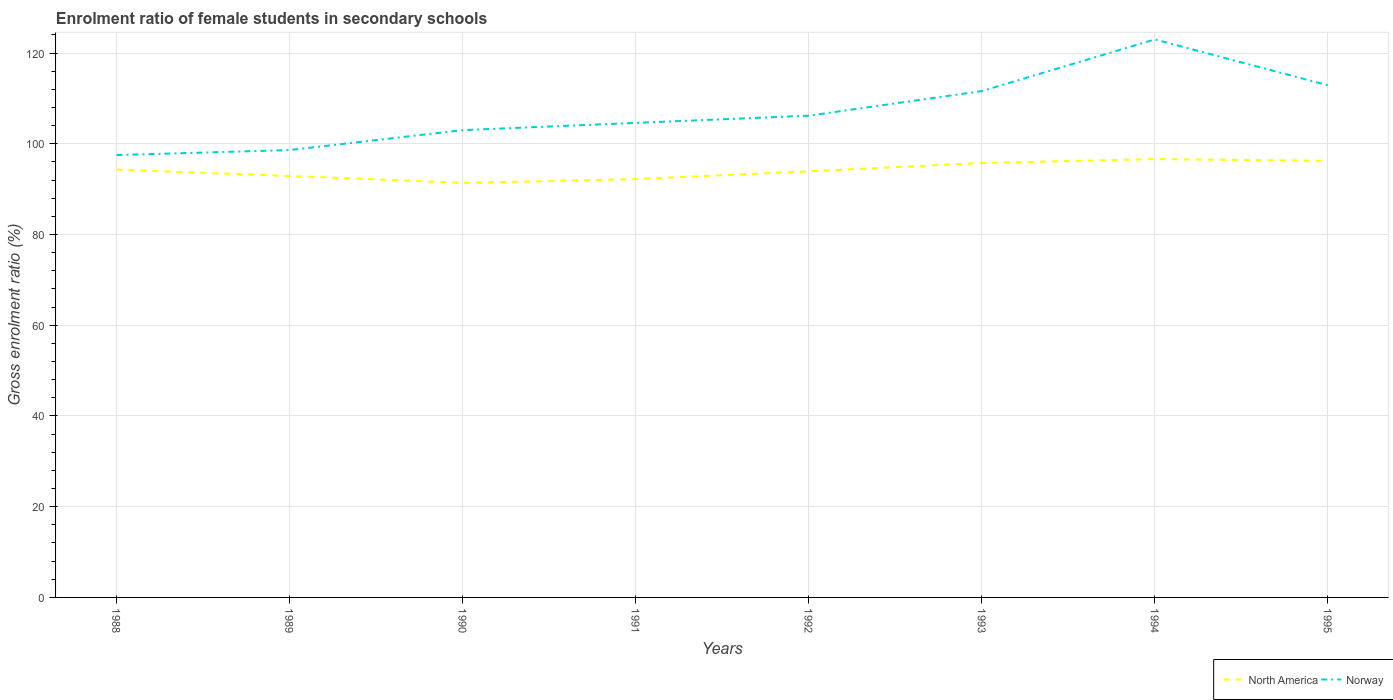How many different coloured lines are there?
Ensure brevity in your answer.  2. Across all years, what is the maximum enrolment ratio of female students in secondary schools in Norway?
Offer a terse response. 97.5. What is the total enrolment ratio of female students in secondary schools in Norway in the graph?
Offer a terse response. -24.39. What is the difference between the highest and the second highest enrolment ratio of female students in secondary schools in North America?
Offer a terse response. 5.23. Is the enrolment ratio of female students in secondary schools in Norway strictly greater than the enrolment ratio of female students in secondary schools in North America over the years?
Provide a short and direct response. No. How many years are there in the graph?
Ensure brevity in your answer.  8. What is the difference between two consecutive major ticks on the Y-axis?
Provide a succinct answer. 20. Are the values on the major ticks of Y-axis written in scientific E-notation?
Make the answer very short. No. How are the legend labels stacked?
Your answer should be very brief. Horizontal. What is the title of the graph?
Your answer should be compact. Enrolment ratio of female students in secondary schools. What is the label or title of the X-axis?
Your answer should be compact. Years. What is the Gross enrolment ratio (%) of North America in 1988?
Offer a terse response. 94.3. What is the Gross enrolment ratio (%) of Norway in 1988?
Offer a terse response. 97.5. What is the Gross enrolment ratio (%) of North America in 1989?
Offer a very short reply. 92.91. What is the Gross enrolment ratio (%) of Norway in 1989?
Your response must be concise. 98.61. What is the Gross enrolment ratio (%) in North America in 1990?
Your answer should be very brief. 91.39. What is the Gross enrolment ratio (%) of Norway in 1990?
Give a very brief answer. 103. What is the Gross enrolment ratio (%) of North America in 1991?
Offer a terse response. 92.21. What is the Gross enrolment ratio (%) of Norway in 1991?
Give a very brief answer. 104.6. What is the Gross enrolment ratio (%) of North America in 1992?
Your response must be concise. 93.93. What is the Gross enrolment ratio (%) in Norway in 1992?
Your answer should be compact. 106.19. What is the Gross enrolment ratio (%) in North America in 1993?
Make the answer very short. 95.76. What is the Gross enrolment ratio (%) in Norway in 1993?
Offer a terse response. 111.61. What is the Gross enrolment ratio (%) of North America in 1994?
Your response must be concise. 96.62. What is the Gross enrolment ratio (%) of Norway in 1994?
Keep it short and to the point. 123. What is the Gross enrolment ratio (%) in North America in 1995?
Your response must be concise. 96.25. What is the Gross enrolment ratio (%) in Norway in 1995?
Provide a short and direct response. 112.89. Across all years, what is the maximum Gross enrolment ratio (%) in North America?
Provide a succinct answer. 96.62. Across all years, what is the maximum Gross enrolment ratio (%) in Norway?
Your answer should be very brief. 123. Across all years, what is the minimum Gross enrolment ratio (%) in North America?
Keep it short and to the point. 91.39. Across all years, what is the minimum Gross enrolment ratio (%) in Norway?
Your response must be concise. 97.5. What is the total Gross enrolment ratio (%) in North America in the graph?
Ensure brevity in your answer.  753.37. What is the total Gross enrolment ratio (%) of Norway in the graph?
Offer a terse response. 857.42. What is the difference between the Gross enrolment ratio (%) of North America in 1988 and that in 1989?
Ensure brevity in your answer.  1.39. What is the difference between the Gross enrolment ratio (%) of Norway in 1988 and that in 1989?
Your answer should be very brief. -1.11. What is the difference between the Gross enrolment ratio (%) of North America in 1988 and that in 1990?
Offer a terse response. 2.91. What is the difference between the Gross enrolment ratio (%) in Norway in 1988 and that in 1990?
Your answer should be very brief. -5.5. What is the difference between the Gross enrolment ratio (%) of North America in 1988 and that in 1991?
Your response must be concise. 2.09. What is the difference between the Gross enrolment ratio (%) in Norway in 1988 and that in 1991?
Provide a short and direct response. -7.1. What is the difference between the Gross enrolment ratio (%) of North America in 1988 and that in 1992?
Offer a very short reply. 0.36. What is the difference between the Gross enrolment ratio (%) in Norway in 1988 and that in 1992?
Make the answer very short. -8.69. What is the difference between the Gross enrolment ratio (%) in North America in 1988 and that in 1993?
Give a very brief answer. -1.47. What is the difference between the Gross enrolment ratio (%) of Norway in 1988 and that in 1993?
Offer a very short reply. -14.11. What is the difference between the Gross enrolment ratio (%) of North America in 1988 and that in 1994?
Ensure brevity in your answer.  -2.32. What is the difference between the Gross enrolment ratio (%) in Norway in 1988 and that in 1994?
Ensure brevity in your answer.  -25.5. What is the difference between the Gross enrolment ratio (%) in North America in 1988 and that in 1995?
Your answer should be very brief. -1.96. What is the difference between the Gross enrolment ratio (%) in Norway in 1988 and that in 1995?
Offer a very short reply. -15.39. What is the difference between the Gross enrolment ratio (%) in North America in 1989 and that in 1990?
Make the answer very short. 1.52. What is the difference between the Gross enrolment ratio (%) of Norway in 1989 and that in 1990?
Ensure brevity in your answer.  -4.39. What is the difference between the Gross enrolment ratio (%) in North America in 1989 and that in 1991?
Offer a very short reply. 0.7. What is the difference between the Gross enrolment ratio (%) of Norway in 1989 and that in 1991?
Offer a very short reply. -5.99. What is the difference between the Gross enrolment ratio (%) in North America in 1989 and that in 1992?
Your response must be concise. -1.03. What is the difference between the Gross enrolment ratio (%) of Norway in 1989 and that in 1992?
Ensure brevity in your answer.  -7.58. What is the difference between the Gross enrolment ratio (%) in North America in 1989 and that in 1993?
Offer a very short reply. -2.86. What is the difference between the Gross enrolment ratio (%) of Norway in 1989 and that in 1993?
Your answer should be very brief. -13. What is the difference between the Gross enrolment ratio (%) in North America in 1989 and that in 1994?
Keep it short and to the point. -3.71. What is the difference between the Gross enrolment ratio (%) of Norway in 1989 and that in 1994?
Give a very brief answer. -24.39. What is the difference between the Gross enrolment ratio (%) in North America in 1989 and that in 1995?
Your answer should be compact. -3.35. What is the difference between the Gross enrolment ratio (%) of Norway in 1989 and that in 1995?
Offer a very short reply. -14.28. What is the difference between the Gross enrolment ratio (%) of North America in 1990 and that in 1991?
Keep it short and to the point. -0.82. What is the difference between the Gross enrolment ratio (%) in Norway in 1990 and that in 1991?
Make the answer very short. -1.6. What is the difference between the Gross enrolment ratio (%) of North America in 1990 and that in 1992?
Offer a terse response. -2.55. What is the difference between the Gross enrolment ratio (%) in Norway in 1990 and that in 1992?
Offer a terse response. -3.19. What is the difference between the Gross enrolment ratio (%) of North America in 1990 and that in 1993?
Give a very brief answer. -4.38. What is the difference between the Gross enrolment ratio (%) of Norway in 1990 and that in 1993?
Provide a succinct answer. -8.61. What is the difference between the Gross enrolment ratio (%) in North America in 1990 and that in 1994?
Keep it short and to the point. -5.23. What is the difference between the Gross enrolment ratio (%) in Norway in 1990 and that in 1994?
Offer a very short reply. -20. What is the difference between the Gross enrolment ratio (%) of North America in 1990 and that in 1995?
Your response must be concise. -4.87. What is the difference between the Gross enrolment ratio (%) in Norway in 1990 and that in 1995?
Provide a succinct answer. -9.89. What is the difference between the Gross enrolment ratio (%) of North America in 1991 and that in 1992?
Keep it short and to the point. -1.73. What is the difference between the Gross enrolment ratio (%) in Norway in 1991 and that in 1992?
Ensure brevity in your answer.  -1.58. What is the difference between the Gross enrolment ratio (%) of North America in 1991 and that in 1993?
Your response must be concise. -3.56. What is the difference between the Gross enrolment ratio (%) of Norway in 1991 and that in 1993?
Offer a very short reply. -7.01. What is the difference between the Gross enrolment ratio (%) in North America in 1991 and that in 1994?
Make the answer very short. -4.41. What is the difference between the Gross enrolment ratio (%) of Norway in 1991 and that in 1994?
Your response must be concise. -18.4. What is the difference between the Gross enrolment ratio (%) of North America in 1991 and that in 1995?
Your answer should be compact. -4.05. What is the difference between the Gross enrolment ratio (%) in Norway in 1991 and that in 1995?
Your response must be concise. -8.29. What is the difference between the Gross enrolment ratio (%) in North America in 1992 and that in 1993?
Keep it short and to the point. -1.83. What is the difference between the Gross enrolment ratio (%) of Norway in 1992 and that in 1993?
Your answer should be very brief. -5.42. What is the difference between the Gross enrolment ratio (%) in North America in 1992 and that in 1994?
Provide a succinct answer. -2.69. What is the difference between the Gross enrolment ratio (%) of Norway in 1992 and that in 1994?
Your response must be concise. -16.81. What is the difference between the Gross enrolment ratio (%) of North America in 1992 and that in 1995?
Provide a short and direct response. -2.32. What is the difference between the Gross enrolment ratio (%) of Norway in 1992 and that in 1995?
Ensure brevity in your answer.  -6.7. What is the difference between the Gross enrolment ratio (%) in North America in 1993 and that in 1994?
Make the answer very short. -0.86. What is the difference between the Gross enrolment ratio (%) in Norway in 1993 and that in 1994?
Keep it short and to the point. -11.39. What is the difference between the Gross enrolment ratio (%) in North America in 1993 and that in 1995?
Ensure brevity in your answer.  -0.49. What is the difference between the Gross enrolment ratio (%) of Norway in 1993 and that in 1995?
Keep it short and to the point. -1.28. What is the difference between the Gross enrolment ratio (%) in North America in 1994 and that in 1995?
Ensure brevity in your answer.  0.37. What is the difference between the Gross enrolment ratio (%) in Norway in 1994 and that in 1995?
Make the answer very short. 10.11. What is the difference between the Gross enrolment ratio (%) of North America in 1988 and the Gross enrolment ratio (%) of Norway in 1989?
Offer a very short reply. -4.32. What is the difference between the Gross enrolment ratio (%) in North America in 1988 and the Gross enrolment ratio (%) in Norway in 1990?
Your answer should be very brief. -8.71. What is the difference between the Gross enrolment ratio (%) of North America in 1988 and the Gross enrolment ratio (%) of Norway in 1991?
Offer a terse response. -10.31. What is the difference between the Gross enrolment ratio (%) of North America in 1988 and the Gross enrolment ratio (%) of Norway in 1992?
Make the answer very short. -11.89. What is the difference between the Gross enrolment ratio (%) of North America in 1988 and the Gross enrolment ratio (%) of Norway in 1993?
Offer a terse response. -17.32. What is the difference between the Gross enrolment ratio (%) of North America in 1988 and the Gross enrolment ratio (%) of Norway in 1994?
Offer a very short reply. -28.71. What is the difference between the Gross enrolment ratio (%) of North America in 1988 and the Gross enrolment ratio (%) of Norway in 1995?
Ensure brevity in your answer.  -18.6. What is the difference between the Gross enrolment ratio (%) in North America in 1989 and the Gross enrolment ratio (%) in Norway in 1990?
Your answer should be very brief. -10.1. What is the difference between the Gross enrolment ratio (%) of North America in 1989 and the Gross enrolment ratio (%) of Norway in 1991?
Give a very brief answer. -11.7. What is the difference between the Gross enrolment ratio (%) of North America in 1989 and the Gross enrolment ratio (%) of Norway in 1992?
Provide a short and direct response. -13.28. What is the difference between the Gross enrolment ratio (%) of North America in 1989 and the Gross enrolment ratio (%) of Norway in 1993?
Your answer should be compact. -18.7. What is the difference between the Gross enrolment ratio (%) of North America in 1989 and the Gross enrolment ratio (%) of Norway in 1994?
Offer a terse response. -30.09. What is the difference between the Gross enrolment ratio (%) in North America in 1989 and the Gross enrolment ratio (%) in Norway in 1995?
Offer a terse response. -19.98. What is the difference between the Gross enrolment ratio (%) in North America in 1990 and the Gross enrolment ratio (%) in Norway in 1991?
Your response must be concise. -13.22. What is the difference between the Gross enrolment ratio (%) of North America in 1990 and the Gross enrolment ratio (%) of Norway in 1992?
Give a very brief answer. -14.8. What is the difference between the Gross enrolment ratio (%) in North America in 1990 and the Gross enrolment ratio (%) in Norway in 1993?
Provide a short and direct response. -20.22. What is the difference between the Gross enrolment ratio (%) of North America in 1990 and the Gross enrolment ratio (%) of Norway in 1994?
Give a very brief answer. -31.61. What is the difference between the Gross enrolment ratio (%) in North America in 1990 and the Gross enrolment ratio (%) in Norway in 1995?
Ensure brevity in your answer.  -21.51. What is the difference between the Gross enrolment ratio (%) of North America in 1991 and the Gross enrolment ratio (%) of Norway in 1992?
Provide a short and direct response. -13.98. What is the difference between the Gross enrolment ratio (%) of North America in 1991 and the Gross enrolment ratio (%) of Norway in 1993?
Give a very brief answer. -19.4. What is the difference between the Gross enrolment ratio (%) in North America in 1991 and the Gross enrolment ratio (%) in Norway in 1994?
Your answer should be very brief. -30.79. What is the difference between the Gross enrolment ratio (%) in North America in 1991 and the Gross enrolment ratio (%) in Norway in 1995?
Keep it short and to the point. -20.68. What is the difference between the Gross enrolment ratio (%) of North America in 1992 and the Gross enrolment ratio (%) of Norway in 1993?
Give a very brief answer. -17.68. What is the difference between the Gross enrolment ratio (%) of North America in 1992 and the Gross enrolment ratio (%) of Norway in 1994?
Give a very brief answer. -29.07. What is the difference between the Gross enrolment ratio (%) in North America in 1992 and the Gross enrolment ratio (%) in Norway in 1995?
Your response must be concise. -18.96. What is the difference between the Gross enrolment ratio (%) in North America in 1993 and the Gross enrolment ratio (%) in Norway in 1994?
Give a very brief answer. -27.24. What is the difference between the Gross enrolment ratio (%) of North America in 1993 and the Gross enrolment ratio (%) of Norway in 1995?
Make the answer very short. -17.13. What is the difference between the Gross enrolment ratio (%) in North America in 1994 and the Gross enrolment ratio (%) in Norway in 1995?
Give a very brief answer. -16.27. What is the average Gross enrolment ratio (%) of North America per year?
Your answer should be compact. 94.17. What is the average Gross enrolment ratio (%) of Norway per year?
Offer a very short reply. 107.18. In the year 1988, what is the difference between the Gross enrolment ratio (%) of North America and Gross enrolment ratio (%) of Norway?
Offer a terse response. -3.21. In the year 1989, what is the difference between the Gross enrolment ratio (%) in North America and Gross enrolment ratio (%) in Norway?
Give a very brief answer. -5.71. In the year 1990, what is the difference between the Gross enrolment ratio (%) of North America and Gross enrolment ratio (%) of Norway?
Provide a succinct answer. -11.62. In the year 1991, what is the difference between the Gross enrolment ratio (%) of North America and Gross enrolment ratio (%) of Norway?
Your response must be concise. -12.4. In the year 1992, what is the difference between the Gross enrolment ratio (%) of North America and Gross enrolment ratio (%) of Norway?
Your response must be concise. -12.26. In the year 1993, what is the difference between the Gross enrolment ratio (%) in North America and Gross enrolment ratio (%) in Norway?
Offer a terse response. -15.85. In the year 1994, what is the difference between the Gross enrolment ratio (%) of North America and Gross enrolment ratio (%) of Norway?
Make the answer very short. -26.38. In the year 1995, what is the difference between the Gross enrolment ratio (%) of North America and Gross enrolment ratio (%) of Norway?
Provide a short and direct response. -16.64. What is the ratio of the Gross enrolment ratio (%) in North America in 1988 to that in 1989?
Provide a short and direct response. 1.01. What is the ratio of the Gross enrolment ratio (%) of Norway in 1988 to that in 1989?
Ensure brevity in your answer.  0.99. What is the ratio of the Gross enrolment ratio (%) in North America in 1988 to that in 1990?
Your response must be concise. 1.03. What is the ratio of the Gross enrolment ratio (%) of Norway in 1988 to that in 1990?
Your answer should be very brief. 0.95. What is the ratio of the Gross enrolment ratio (%) of North America in 1988 to that in 1991?
Your response must be concise. 1.02. What is the ratio of the Gross enrolment ratio (%) in Norway in 1988 to that in 1991?
Your response must be concise. 0.93. What is the ratio of the Gross enrolment ratio (%) of North America in 1988 to that in 1992?
Offer a very short reply. 1. What is the ratio of the Gross enrolment ratio (%) of Norway in 1988 to that in 1992?
Your response must be concise. 0.92. What is the ratio of the Gross enrolment ratio (%) of North America in 1988 to that in 1993?
Provide a short and direct response. 0.98. What is the ratio of the Gross enrolment ratio (%) in Norway in 1988 to that in 1993?
Make the answer very short. 0.87. What is the ratio of the Gross enrolment ratio (%) of North America in 1988 to that in 1994?
Ensure brevity in your answer.  0.98. What is the ratio of the Gross enrolment ratio (%) in Norway in 1988 to that in 1994?
Your answer should be very brief. 0.79. What is the ratio of the Gross enrolment ratio (%) of North America in 1988 to that in 1995?
Provide a short and direct response. 0.98. What is the ratio of the Gross enrolment ratio (%) in Norway in 1988 to that in 1995?
Offer a terse response. 0.86. What is the ratio of the Gross enrolment ratio (%) of North America in 1989 to that in 1990?
Provide a short and direct response. 1.02. What is the ratio of the Gross enrolment ratio (%) of Norway in 1989 to that in 1990?
Provide a short and direct response. 0.96. What is the ratio of the Gross enrolment ratio (%) of North America in 1989 to that in 1991?
Keep it short and to the point. 1.01. What is the ratio of the Gross enrolment ratio (%) of Norway in 1989 to that in 1991?
Make the answer very short. 0.94. What is the ratio of the Gross enrolment ratio (%) of Norway in 1989 to that in 1992?
Offer a terse response. 0.93. What is the ratio of the Gross enrolment ratio (%) in North America in 1989 to that in 1993?
Offer a terse response. 0.97. What is the ratio of the Gross enrolment ratio (%) in Norway in 1989 to that in 1993?
Your answer should be compact. 0.88. What is the ratio of the Gross enrolment ratio (%) in North America in 1989 to that in 1994?
Keep it short and to the point. 0.96. What is the ratio of the Gross enrolment ratio (%) in Norway in 1989 to that in 1994?
Give a very brief answer. 0.8. What is the ratio of the Gross enrolment ratio (%) of North America in 1989 to that in 1995?
Keep it short and to the point. 0.97. What is the ratio of the Gross enrolment ratio (%) in Norway in 1989 to that in 1995?
Give a very brief answer. 0.87. What is the ratio of the Gross enrolment ratio (%) in North America in 1990 to that in 1991?
Provide a succinct answer. 0.99. What is the ratio of the Gross enrolment ratio (%) in Norway in 1990 to that in 1991?
Your answer should be compact. 0.98. What is the ratio of the Gross enrolment ratio (%) in North America in 1990 to that in 1992?
Provide a short and direct response. 0.97. What is the ratio of the Gross enrolment ratio (%) of Norway in 1990 to that in 1992?
Provide a succinct answer. 0.97. What is the ratio of the Gross enrolment ratio (%) in North America in 1990 to that in 1993?
Give a very brief answer. 0.95. What is the ratio of the Gross enrolment ratio (%) in Norway in 1990 to that in 1993?
Keep it short and to the point. 0.92. What is the ratio of the Gross enrolment ratio (%) of North America in 1990 to that in 1994?
Offer a terse response. 0.95. What is the ratio of the Gross enrolment ratio (%) of Norway in 1990 to that in 1994?
Offer a terse response. 0.84. What is the ratio of the Gross enrolment ratio (%) in North America in 1990 to that in 1995?
Keep it short and to the point. 0.95. What is the ratio of the Gross enrolment ratio (%) in Norway in 1990 to that in 1995?
Provide a short and direct response. 0.91. What is the ratio of the Gross enrolment ratio (%) in North America in 1991 to that in 1992?
Offer a terse response. 0.98. What is the ratio of the Gross enrolment ratio (%) of Norway in 1991 to that in 1992?
Ensure brevity in your answer.  0.99. What is the ratio of the Gross enrolment ratio (%) in North America in 1991 to that in 1993?
Ensure brevity in your answer.  0.96. What is the ratio of the Gross enrolment ratio (%) of Norway in 1991 to that in 1993?
Make the answer very short. 0.94. What is the ratio of the Gross enrolment ratio (%) of North America in 1991 to that in 1994?
Your response must be concise. 0.95. What is the ratio of the Gross enrolment ratio (%) in Norway in 1991 to that in 1994?
Offer a very short reply. 0.85. What is the ratio of the Gross enrolment ratio (%) in North America in 1991 to that in 1995?
Give a very brief answer. 0.96. What is the ratio of the Gross enrolment ratio (%) in Norway in 1991 to that in 1995?
Your response must be concise. 0.93. What is the ratio of the Gross enrolment ratio (%) in North America in 1992 to that in 1993?
Your answer should be very brief. 0.98. What is the ratio of the Gross enrolment ratio (%) in Norway in 1992 to that in 1993?
Offer a very short reply. 0.95. What is the ratio of the Gross enrolment ratio (%) of North America in 1992 to that in 1994?
Your answer should be very brief. 0.97. What is the ratio of the Gross enrolment ratio (%) of Norway in 1992 to that in 1994?
Offer a terse response. 0.86. What is the ratio of the Gross enrolment ratio (%) of North America in 1992 to that in 1995?
Your answer should be compact. 0.98. What is the ratio of the Gross enrolment ratio (%) in Norway in 1992 to that in 1995?
Ensure brevity in your answer.  0.94. What is the ratio of the Gross enrolment ratio (%) of North America in 1993 to that in 1994?
Your answer should be compact. 0.99. What is the ratio of the Gross enrolment ratio (%) in Norway in 1993 to that in 1994?
Provide a succinct answer. 0.91. What is the ratio of the Gross enrolment ratio (%) in Norway in 1993 to that in 1995?
Give a very brief answer. 0.99. What is the ratio of the Gross enrolment ratio (%) in North America in 1994 to that in 1995?
Your answer should be very brief. 1. What is the ratio of the Gross enrolment ratio (%) of Norway in 1994 to that in 1995?
Your answer should be very brief. 1.09. What is the difference between the highest and the second highest Gross enrolment ratio (%) in North America?
Ensure brevity in your answer.  0.37. What is the difference between the highest and the second highest Gross enrolment ratio (%) of Norway?
Make the answer very short. 10.11. What is the difference between the highest and the lowest Gross enrolment ratio (%) in North America?
Provide a short and direct response. 5.23. What is the difference between the highest and the lowest Gross enrolment ratio (%) in Norway?
Keep it short and to the point. 25.5. 